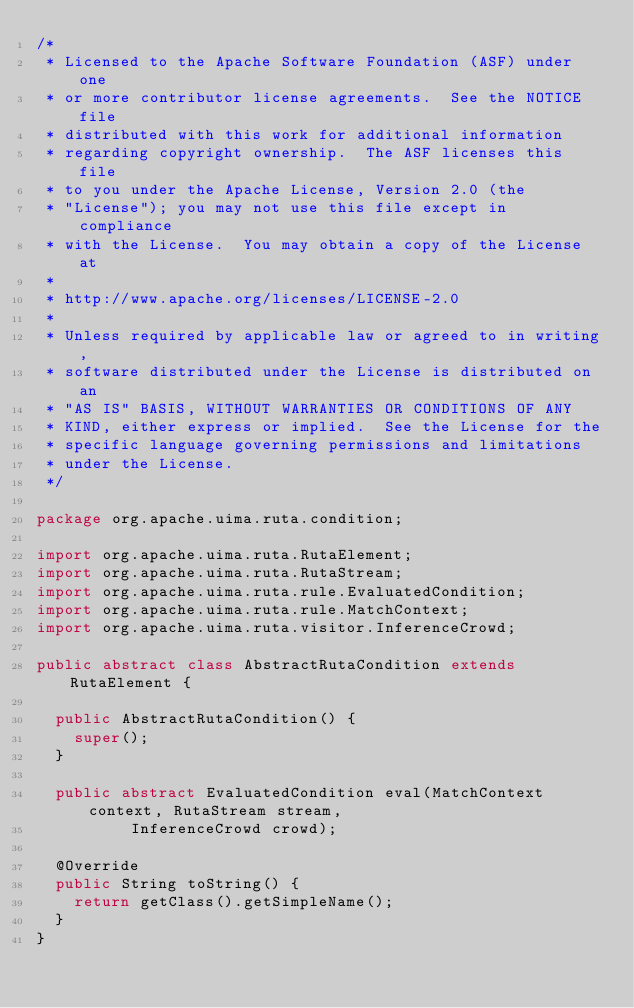<code> <loc_0><loc_0><loc_500><loc_500><_Java_>/*
 * Licensed to the Apache Software Foundation (ASF) under one
 * or more contributor license agreements.  See the NOTICE file
 * distributed with this work for additional information
 * regarding copyright ownership.  The ASF licenses this file
 * to you under the Apache License, Version 2.0 (the
 * "License"); you may not use this file except in compliance
 * with the License.  You may obtain a copy of the License at
 * 
 * http://www.apache.org/licenses/LICENSE-2.0
 * 
 * Unless required by applicable law or agreed to in writing,
 * software distributed under the License is distributed on an
 * "AS IS" BASIS, WITHOUT WARRANTIES OR CONDITIONS OF ANY
 * KIND, either express or implied.  See the License for the
 * specific language governing permissions and limitations
 * under the License.
 */

package org.apache.uima.ruta.condition;

import org.apache.uima.ruta.RutaElement;
import org.apache.uima.ruta.RutaStream;
import org.apache.uima.ruta.rule.EvaluatedCondition;
import org.apache.uima.ruta.rule.MatchContext;
import org.apache.uima.ruta.visitor.InferenceCrowd;

public abstract class AbstractRutaCondition extends RutaElement {

  public AbstractRutaCondition() {
    super();
  }

  public abstract EvaluatedCondition eval(MatchContext context, RutaStream stream,
          InferenceCrowd crowd);

  @Override
  public String toString() {
    return getClass().getSimpleName();
  }
}
</code> 